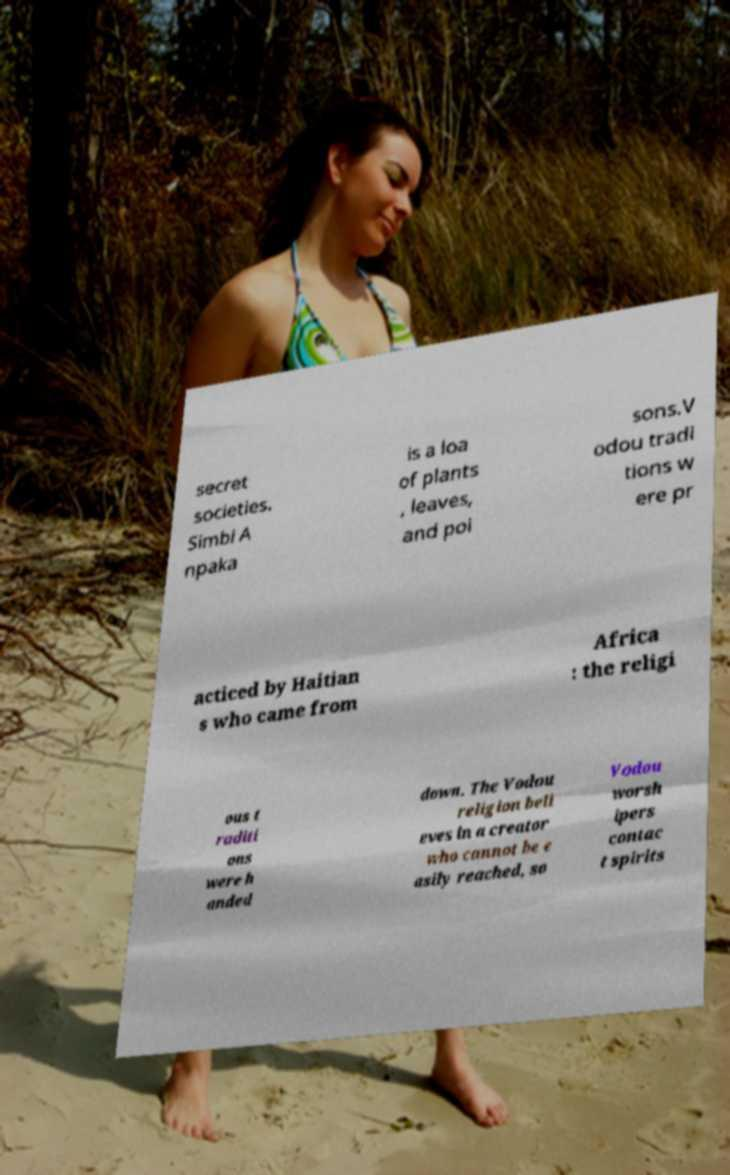For documentation purposes, I need the text within this image transcribed. Could you provide that? secret societies. Simbi A npaka is a loa of plants , leaves, and poi sons.V odou tradi tions w ere pr acticed by Haitian s who came from Africa : the religi ous t raditi ons were h anded down. The Vodou religion beli eves in a creator who cannot be e asily reached, so Vodou worsh ipers contac t spirits 